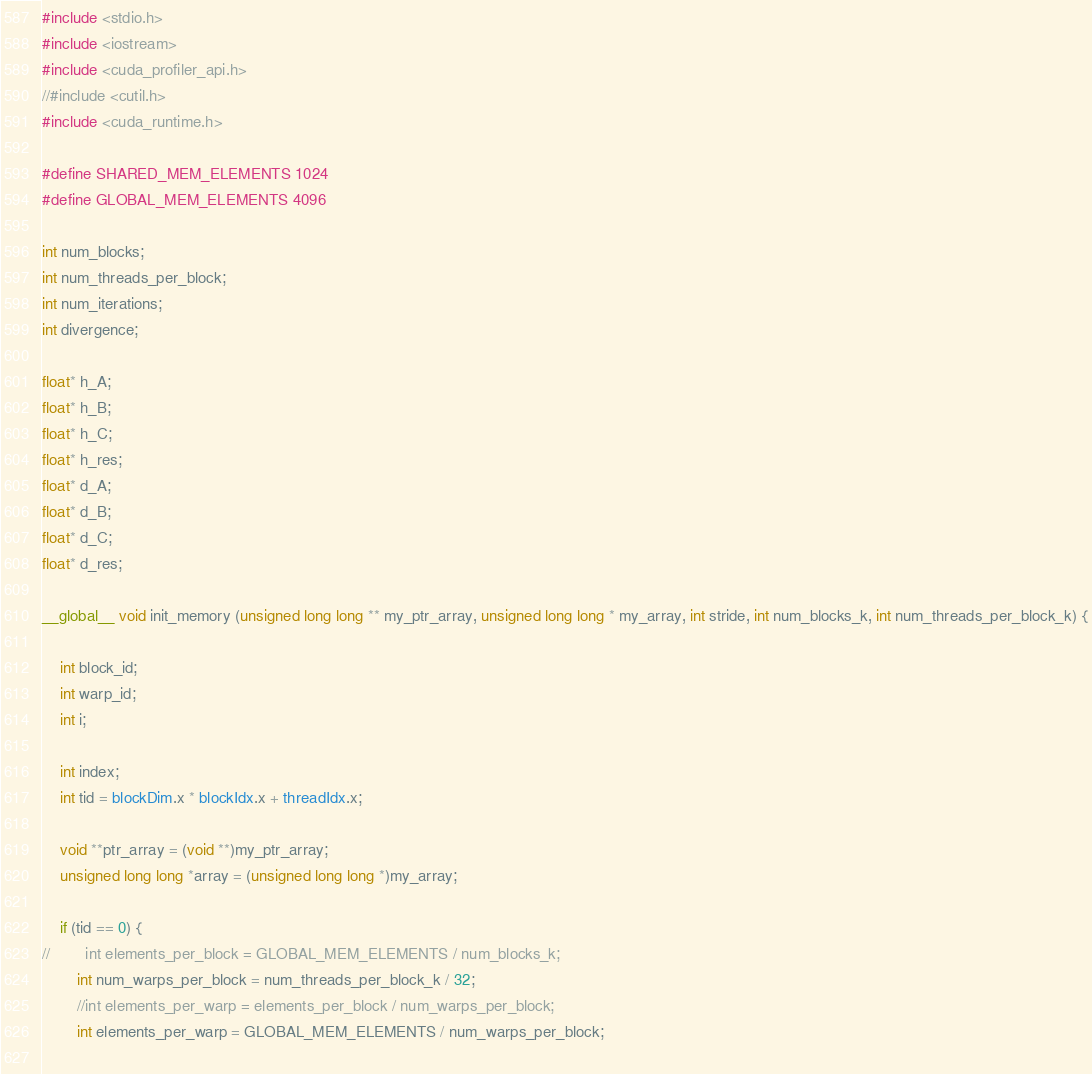<code> <loc_0><loc_0><loc_500><loc_500><_Cuda_>#include <stdio.h>
#include <iostream>
#include <cuda_profiler_api.h>
//#include <cutil.h>
#include <cuda_runtime.h>

#define SHARED_MEM_ELEMENTS 1024
#define GLOBAL_MEM_ELEMENTS 4096

int num_blocks;
int num_threads_per_block;
int num_iterations;
int divergence;

float* h_A;
float* h_B;
float* h_C;
float* h_res;
float* d_A;
float* d_B;
float* d_C;
float* d_res;

__global__ void init_memory (unsigned long long ** my_ptr_array, unsigned long long * my_array, int stride, int num_blocks_k, int num_threads_per_block_k) {

    int block_id;
    int warp_id;
    int i;

    int index;
    int tid = blockDim.x * blockIdx.x + threadIdx.x;

    void **ptr_array = (void **)my_ptr_array;
    unsigned long long *array = (unsigned long long *)my_array;

    if (tid == 0) {
//        int elements_per_block = GLOBAL_MEM_ELEMENTS / num_blocks_k;
        int num_warps_per_block = num_threads_per_block_k / 32;
        //int elements_per_warp = elements_per_block / num_warps_per_block;
        int elements_per_warp = GLOBAL_MEM_ELEMENTS / num_warps_per_block;
        </code> 